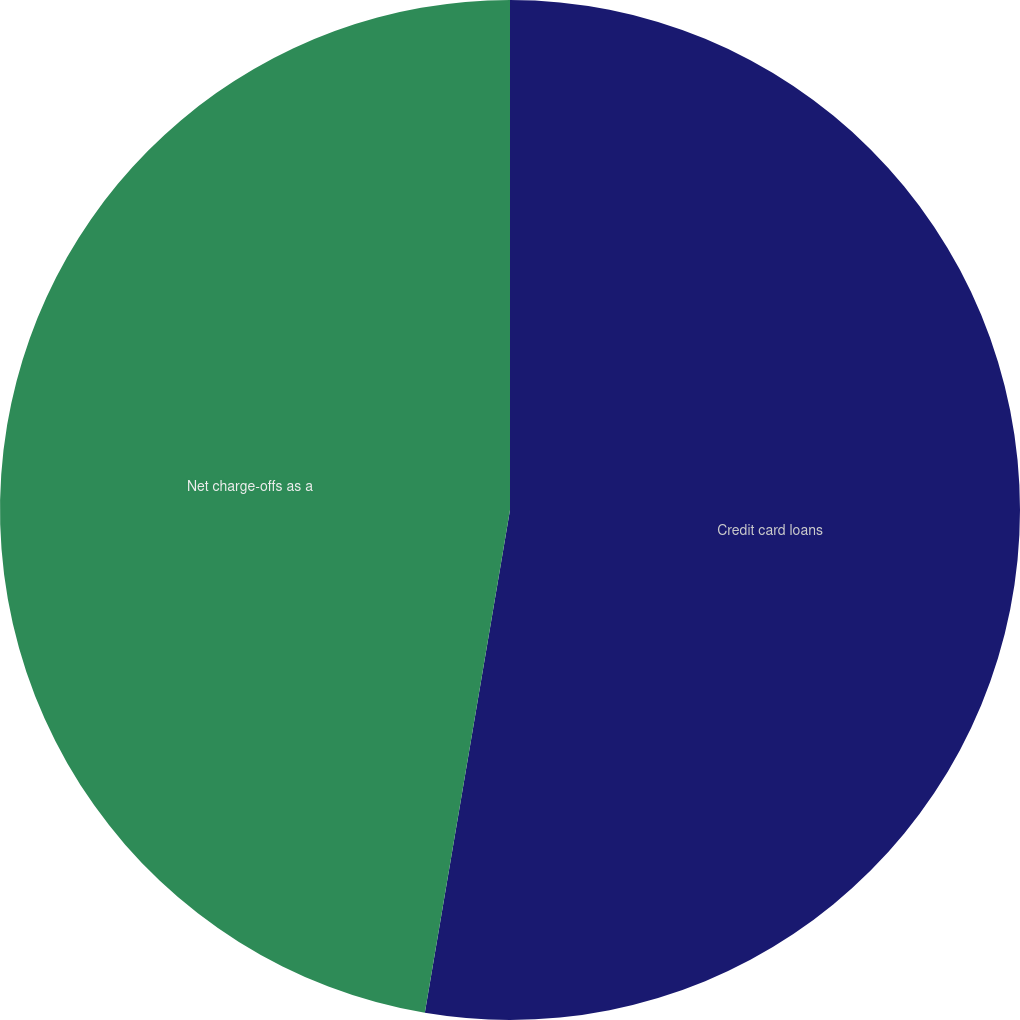<chart> <loc_0><loc_0><loc_500><loc_500><pie_chart><fcel>Credit card loans<fcel>Net charge-offs as a<nl><fcel>52.67%<fcel>47.33%<nl></chart> 